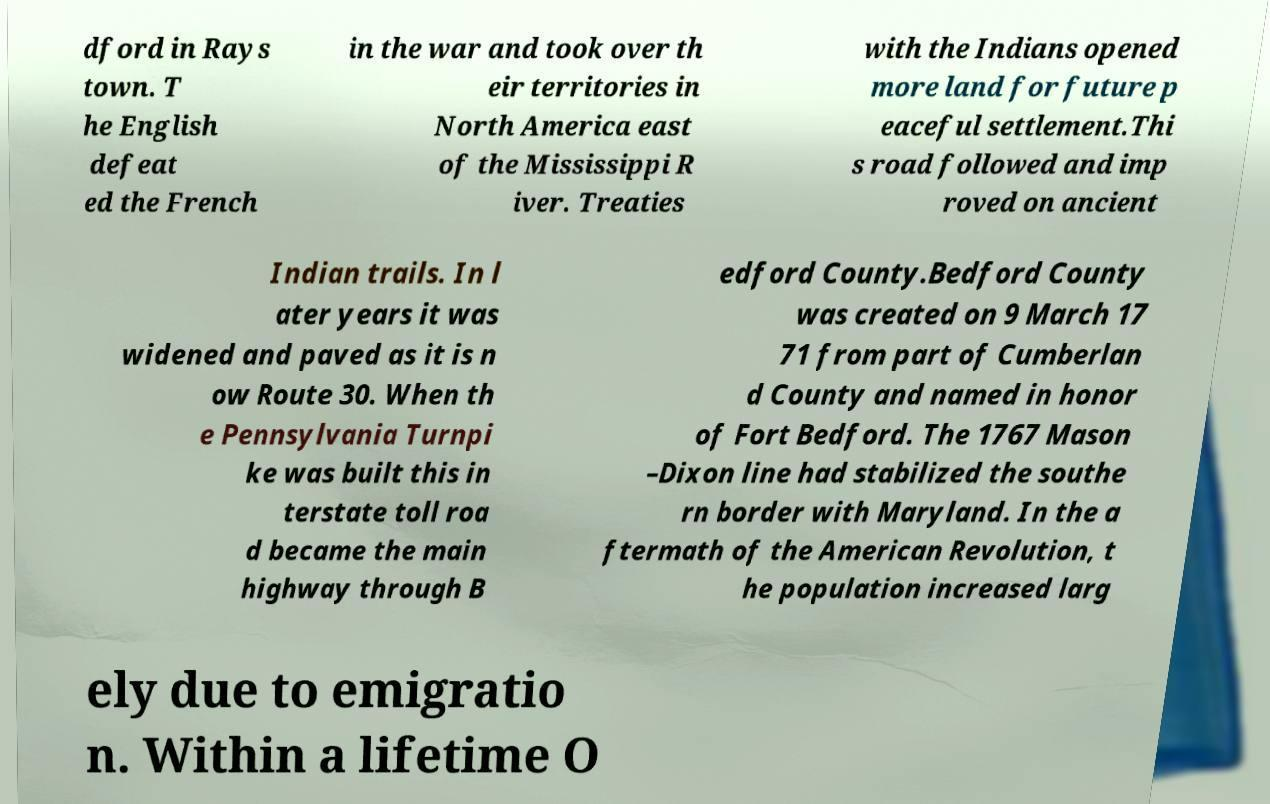Please identify and transcribe the text found in this image. dford in Rays town. T he English defeat ed the French in the war and took over th eir territories in North America east of the Mississippi R iver. Treaties with the Indians opened more land for future p eaceful settlement.Thi s road followed and imp roved on ancient Indian trails. In l ater years it was widened and paved as it is n ow Route 30. When th e Pennsylvania Turnpi ke was built this in terstate toll roa d became the main highway through B edford County.Bedford County was created on 9 March 17 71 from part of Cumberlan d County and named in honor of Fort Bedford. The 1767 Mason –Dixon line had stabilized the southe rn border with Maryland. In the a ftermath of the American Revolution, t he population increased larg ely due to emigratio n. Within a lifetime O 